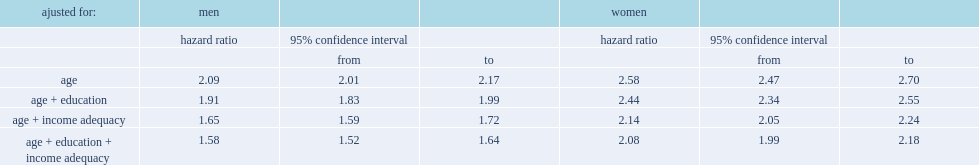When only age were taken into account, what was the hazard ratio for dying from avoidable causes for first nations cohort men? 2.09. When educational attainment and income adequacy were taken into account, what was the hazard ratio for dying from avoidable causes for first nations cohort men? 1.58. When only age were taken into account, what was the hazard ratio for dying from avoidable causes for first nations cohort women? 2.58. When educational attainment and income adequacy were taken into account, what was the hazard ratio for dying from avoidable causes for first nations cohort women? 2.08. 